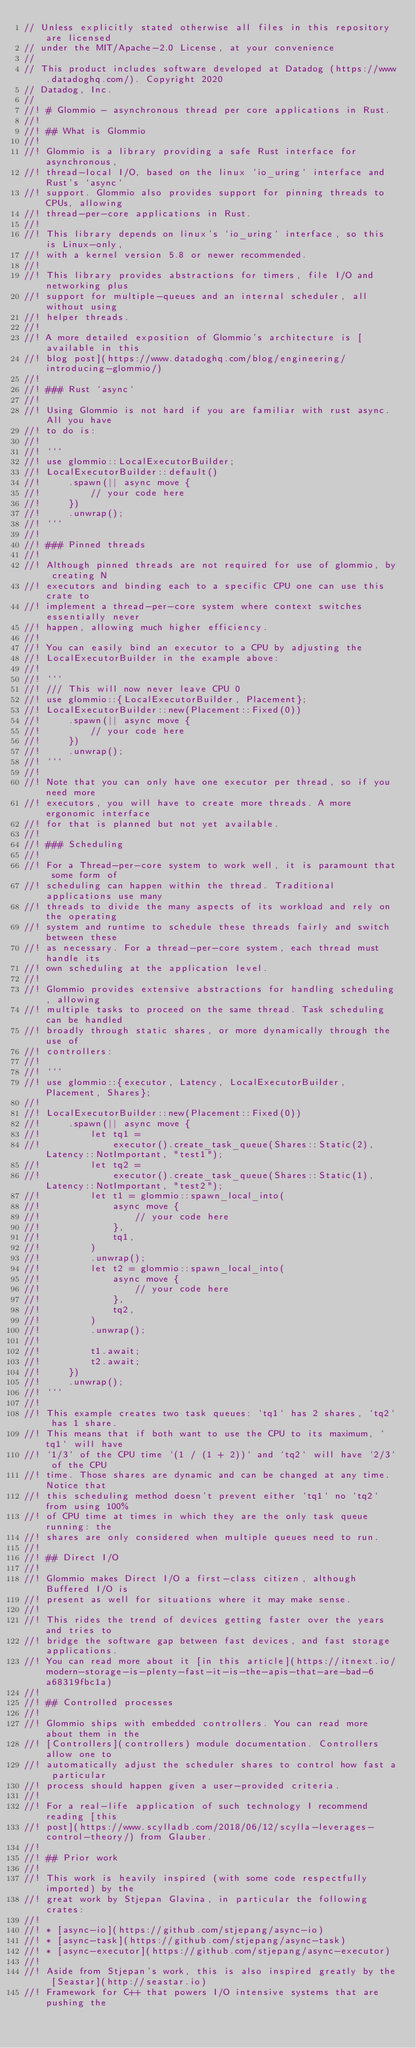Convert code to text. <code><loc_0><loc_0><loc_500><loc_500><_Rust_>// Unless explicitly stated otherwise all files in this repository are licensed
// under the MIT/Apache-2.0 License, at your convenience
//
// This product includes software developed at Datadog (https://www.datadoghq.com/). Copyright 2020
// Datadog, Inc.
//
//! # Glommio - asynchronous thread per core applications in Rust.
//!
//! ## What is Glommio
//!
//! Glommio is a library providing a safe Rust interface for asynchronous,
//! thread-local I/O, based on the linux `io_uring` interface and Rust's `async`
//! support. Glommio also provides support for pinning threads to CPUs, allowing
//! thread-per-core applications in Rust.
//!
//! This library depends on linux's `io_uring` interface, so this is Linux-only,
//! with a kernel version 5.8 or newer recommended.
//!
//! This library provides abstractions for timers, file I/O and networking plus
//! support for multiple-queues and an internal scheduler, all without using
//! helper threads.
//!
//! A more detailed exposition of Glommio's architecture is [available in this
//! blog post](https://www.datadoghq.com/blog/engineering/introducing-glommio/)
//!
//! ### Rust `async`
//!
//! Using Glommio is not hard if you are familiar with rust async. All you have
//! to do is:
//!
//! ```
//! use glommio::LocalExecutorBuilder;
//! LocalExecutorBuilder::default()
//!     .spawn(|| async move {
//!         // your code here
//!     })
//!     .unwrap();
//! ```
//!
//! ### Pinned threads
//!
//! Although pinned threads are not required for use of glommio, by creating N
//! executors and binding each to a specific CPU one can use this crate to
//! implement a thread-per-core system where context switches essentially never
//! happen, allowing much higher efficiency.
//!
//! You can easily bind an executor to a CPU by adjusting the
//! LocalExecutorBuilder in the example above:
//!
//! ```
//! /// This will now never leave CPU 0
//! use glommio::{LocalExecutorBuilder, Placement};
//! LocalExecutorBuilder::new(Placement::Fixed(0))
//!     .spawn(|| async move {
//!         // your code here
//!     })
//!     .unwrap();
//! ```
//!
//! Note that you can only have one executor per thread, so if you need more
//! executors, you will have to create more threads. A more ergonomic interface
//! for that is planned but not yet available.
//!
//! ### Scheduling
//!
//! For a Thread-per-core system to work well, it is paramount that some form of
//! scheduling can happen within the thread. Traditional applications use many
//! threads to divide the many aspects of its workload and rely on the operating
//! system and runtime to schedule these threads fairly and switch between these
//! as necessary. For a thread-per-core system, each thread must handle its
//! own scheduling at the application level.
//!
//! Glommio provides extensive abstractions for handling scheduling, allowing
//! multiple tasks to proceed on the same thread. Task scheduling can be handled
//! broadly through static shares, or more dynamically through the use of
//! controllers:
//!
//! ```
//! use glommio::{executor, Latency, LocalExecutorBuilder, Placement, Shares};
//!
//! LocalExecutorBuilder::new(Placement::Fixed(0))
//!     .spawn(|| async move {
//!         let tq1 =
//!             executor().create_task_queue(Shares::Static(2), Latency::NotImportant, "test1");
//!         let tq2 =
//!             executor().create_task_queue(Shares::Static(1), Latency::NotImportant, "test2");
//!         let t1 = glommio::spawn_local_into(
//!             async move {
//!                 // your code here
//!             },
//!             tq1,
//!         )
//!         .unwrap();
//!         let t2 = glommio::spawn_local_into(
//!             async move {
//!                 // your code here
//!             },
//!             tq2,
//!         )
//!         .unwrap();
//!
//!         t1.await;
//!         t2.await;
//!     })
//!     .unwrap();
//! ```
//!
//! This example creates two task queues: `tq1` has 2 shares, `tq2` has 1 share.
//! This means that if both want to use the CPU to its maximum, `tq1` will have
//! `1/3` of the CPU time `(1 / (1 + 2))` and `tq2` will have `2/3` of the CPU
//! time. Those shares are dynamic and can be changed at any time. Notice that
//! this scheduling method doesn't prevent either `tq1` no `tq2` from using 100%
//! of CPU time at times in which they are the only task queue running: the
//! shares are only considered when multiple queues need to run.
//!
//! ## Direct I/O
//!
//! Glommio makes Direct I/O a first-class citizen, although Buffered I/O is
//! present as well for situations where it may make sense.
//!
//! This rides the trend of devices getting faster over the years and tries to
//! bridge the software gap between fast devices, and fast storage applications.
//! You can read more about it [in this article](https://itnext.io/modern-storage-is-plenty-fast-it-is-the-apis-that-are-bad-6a68319fbc1a)
//!
//! ## Controlled processes
//!
//! Glommio ships with embedded controllers. You can read more about them in the
//! [Controllers](controllers) module documentation. Controllers allow one to
//! automatically adjust the scheduler shares to control how fast a particular
//! process should happen given a user-provided criteria.
//!
//! For a real-life application of such technology I recommend reading [this
//! post](https://www.scylladb.com/2018/06/12/scylla-leverages-control-theory/) from Glauber.
//!
//! ## Prior work
//!
//! This work is heavily inspired (with some code respectfully imported) by the
//! great work by Stjepan Glavina, in particular the following crates:
//!
//! * [async-io](https://github.com/stjepang/async-io)
//! * [async-task](https://github.com/stjepang/async-task)
//! * [async-executor](https://github.com/stjepang/async-executor)
//!
//! Aside from Stjepan's work, this is also inspired greatly by the [Seastar](http://seastar.io)
//! Framework for C++ that powers I/O intensive systems that are pushing the</code> 